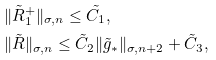Convert formula to latex. <formula><loc_0><loc_0><loc_500><loc_500>& \| \tilde { R } ^ { + } _ { 1 } \| _ { \sigma , n } \leq \tilde { C _ { 1 } } , \\ & \| \tilde { R } \| _ { \sigma , n } \leq \tilde { C } _ { 2 } \| \tilde { g } _ { * } \| _ { \sigma , n + 2 } + \tilde { C } _ { 3 } ,</formula> 